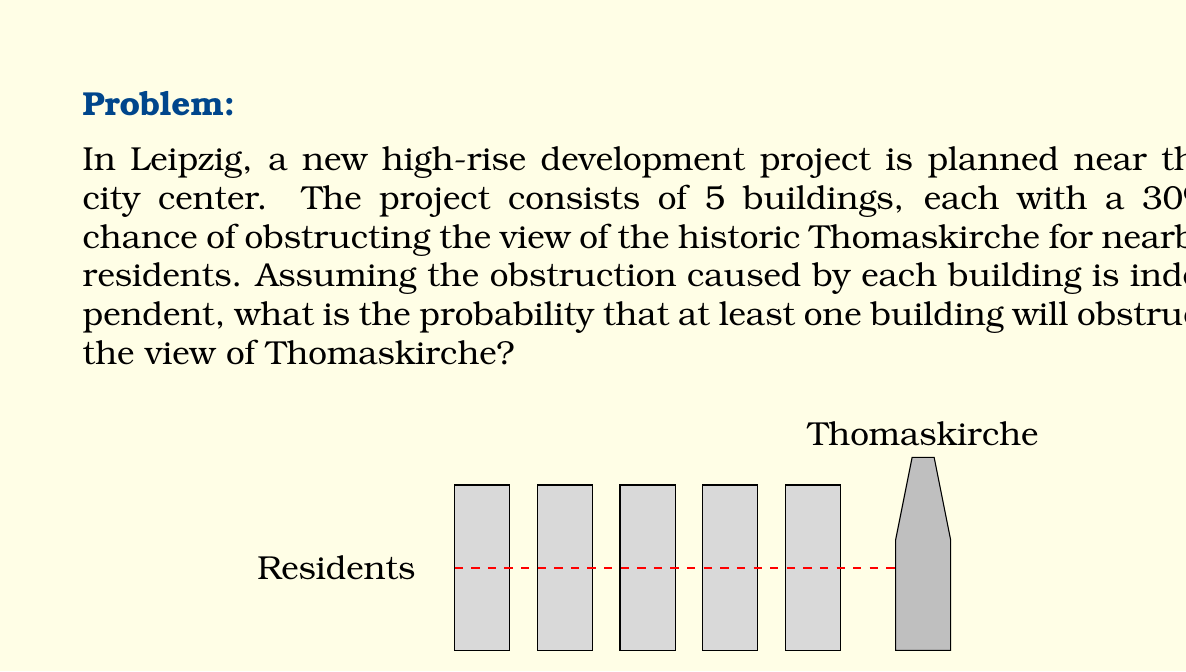Help me with this question. Let's approach this step-by-step:

1) First, let's define our events:
   Let $A_i$ be the event that building $i$ obstructs the view.

2) We're given that $P(A_i) = 0.30$ for each building.

3) We want to find the probability that at least one building obstructs the view. It's easier to calculate the probability of the complement event: that no buildings obstruct the view.

4) The probability that a single building does not obstruct the view is:
   $P(\text{not } A_i) = 1 - P(A_i) = 1 - 0.30 = 0.70$

5) Since the obstructions are independent, we can multiply the individual probabilities:
   $P(\text{no obstruction}) = 0.70 ^ 5 = 0.16807$

6) Therefore, the probability of at least one obstruction is:
   $P(\text{at least one obstruction}) = 1 - P(\text{no obstruction})$
   $= 1 - 0.16807 = 0.83193$

7) Converting to a percentage:
   $0.83193 \times 100\% = 83.193\%$
Answer: 83.193% 